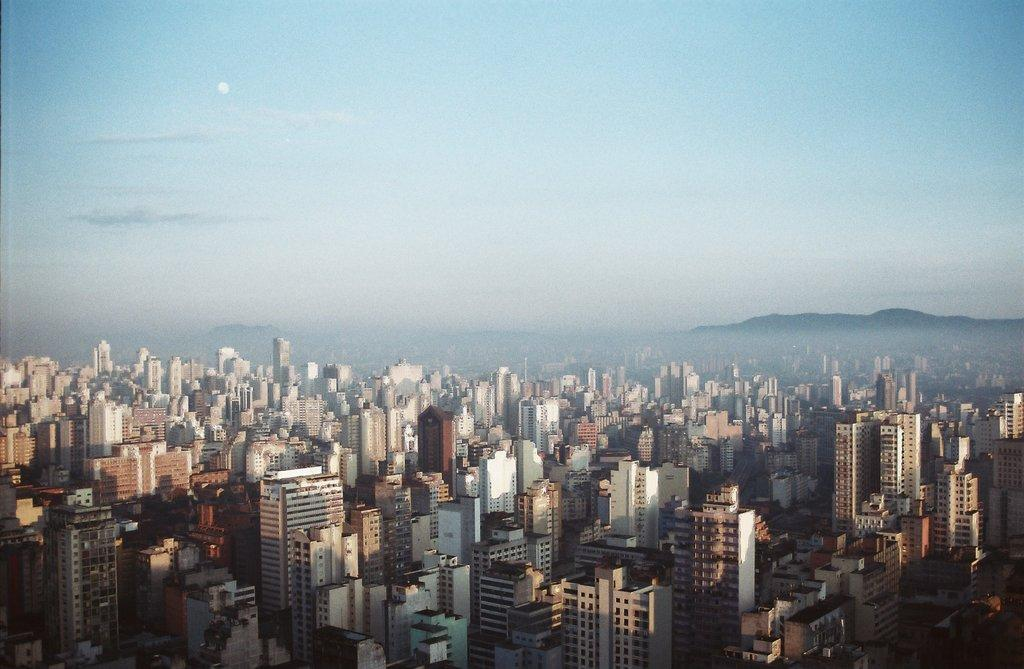What type of structures can be seen in the image? There are buildings in the image. What is visible at the top of the image? The sky is visible at the top of the image. How many cows are present in the image? There are no cows or cattle present in the image; it features buildings and the sky. What type of watch is being worn by the question in the image? There is no person or watch visible in the image. 